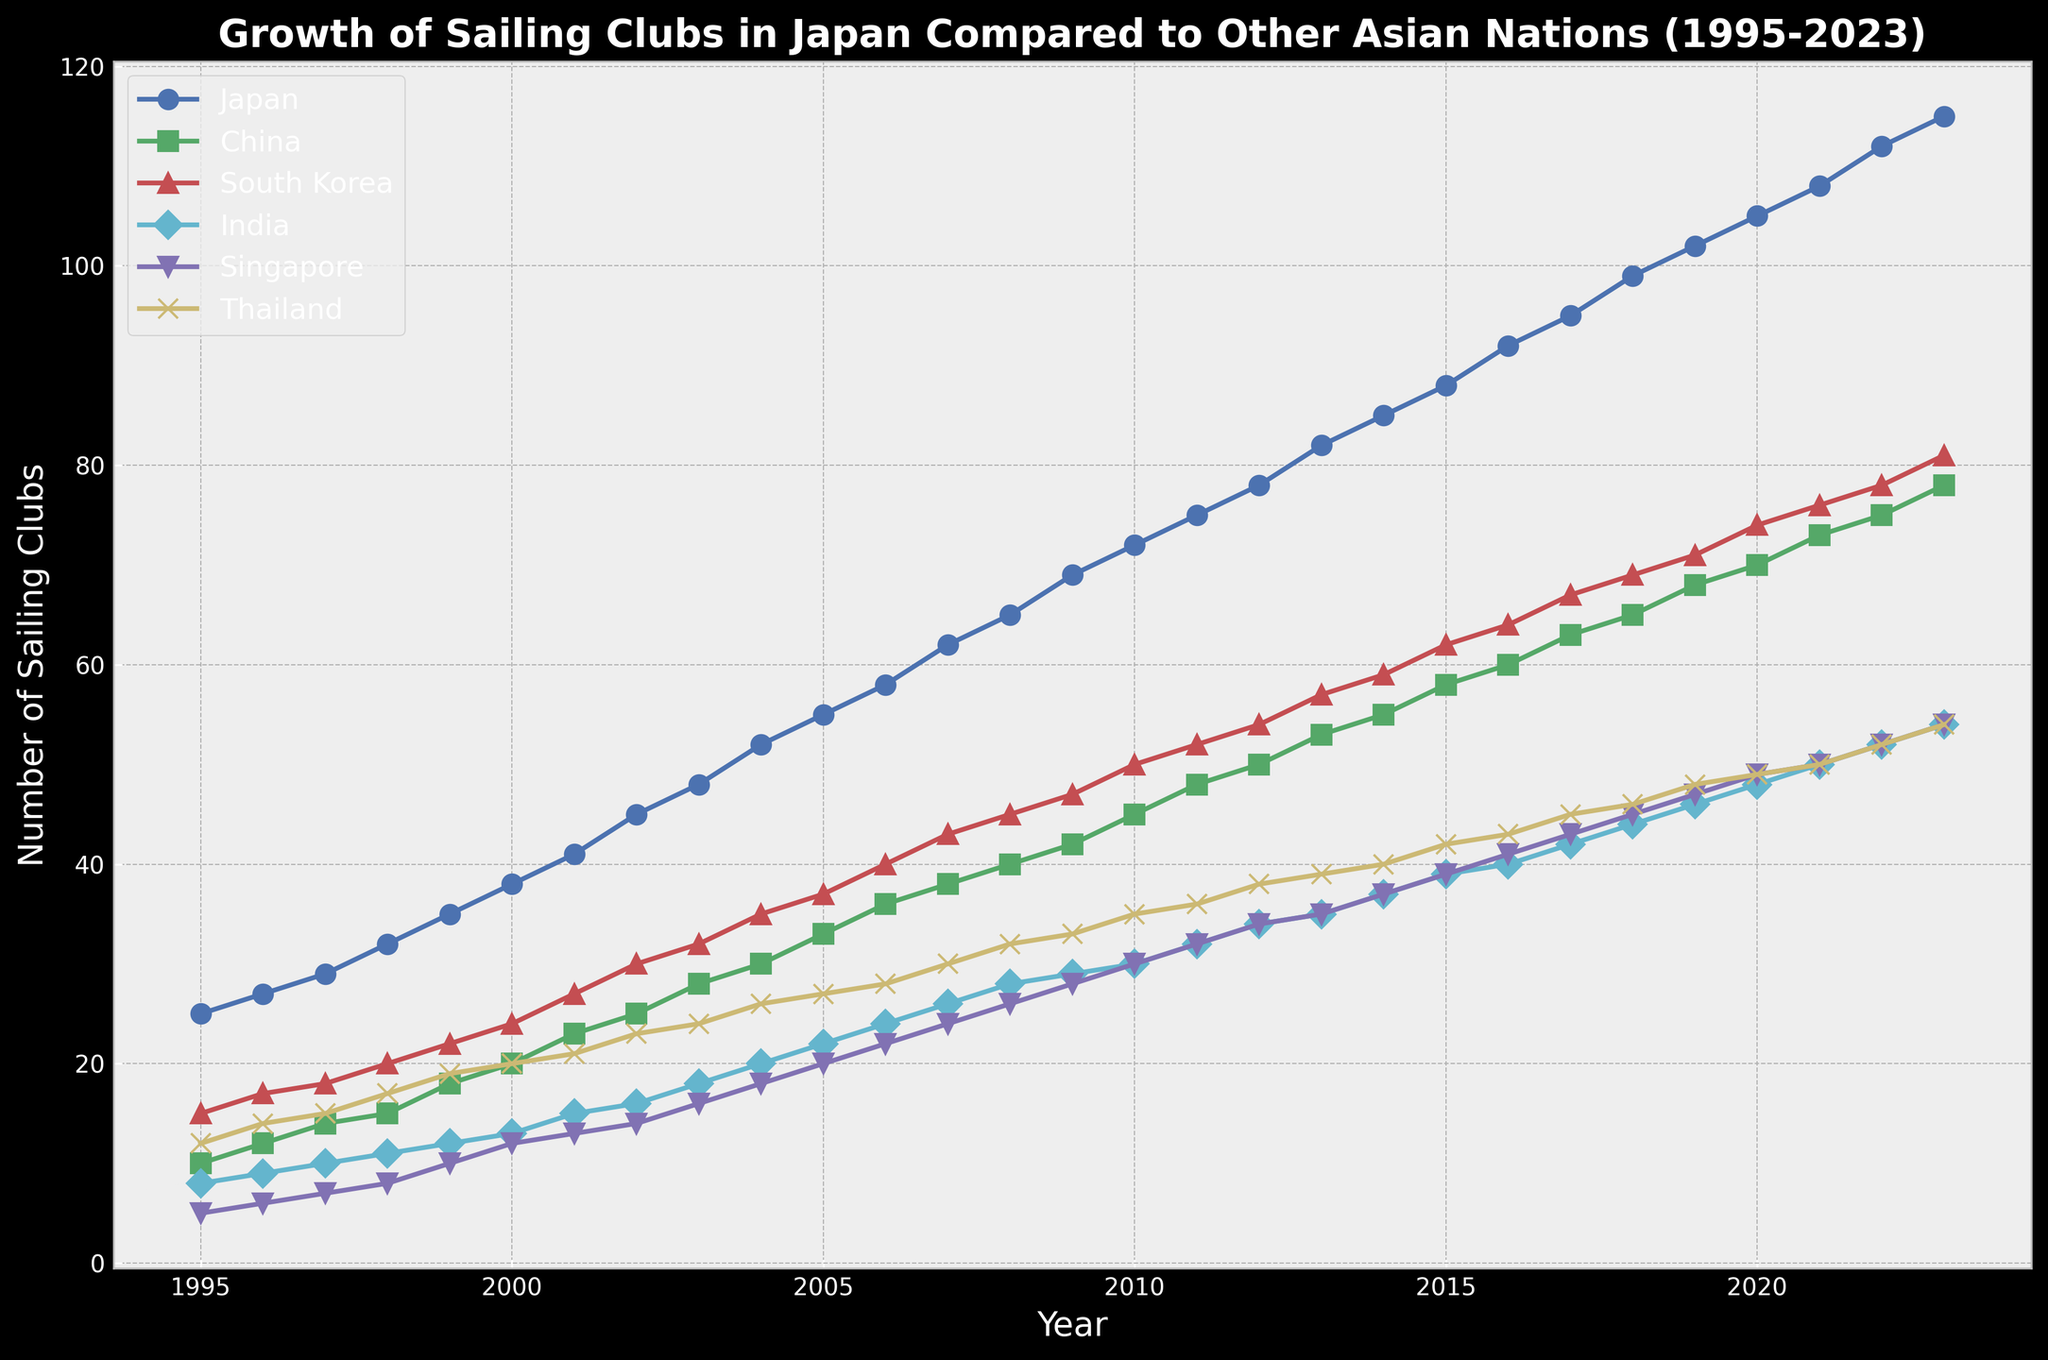How many sailing clubs did Japan and China have in 2003 combined? To find the combined number of sailing clubs in Japan and China in 2003, locate the data points for Japan and China for the year 2003, then add them together. For 2003, Japan had 48 clubs and China had 28 clubs. Therefore, 48 + 28 = 76.
Answer: 76 Between which years did Japan experience the greatest increase in the number of sailing clubs? To determine the period of greatest increase for Japan, compare the increase in the number of sailing clubs between each consecutive year. The steepest increase occurred between 2011 and 2012, where Japan's sailing clubs grew from 75 to 78, an increase of 3 clubs.
Answer: 2011 to 2012 Which country had the highest number of sailing clubs in 2023? To identify the country with the highest number of sailing clubs in 2023, compare the data for each country for the year 2023. Japan had the highest number with 115 sailing clubs.
Answer: Japan From 1995 to 2023, did Singapore ever have more sailing clubs than South Korea? To determine if Singapore ever had more clubs than South Korea, compare their values year by year. At no point did Singapore exceed South Korea in the number of sailing clubs between 1995 and 2023.
Answer: No How many sailing clubs did India have in 2023 compared to 1995? To compare India's number of sailing clubs in 2023 to 1995, find the values for both years. In 1995, India had 8 clubs, and in 2023, it had 54. The difference is 54 - 8 = 46.
Answer: 46 Which country showed the least growth in sailing clubs from 1995 to 2023? To determine the country with the least growth, subtract the number of clubs in 1995 from the number in 2023 for each country and identify the smallest value. Singapore had 5 clubs in 1995 and 54 in 2023, giving a growth of 54 - 5 = 49 clubs. This is the smallest growth among the countries listed.
Answer: Singapore In which year did Thailand first have as many sailing clubs as India? To find the year when Thailand first had as many sailing clubs as India, compare their values year by year. In 2007, both Thailand and India had 26 clubs, which is the first instance of equality.
Answer: 2007 What was the total number of sailing clubs across all listed countries in 2010? To find the total number of sailing clubs across all countries in 2010, sum the values for each country for that year: Japan (72), China (45), South Korea (50), India (30), Singapore (30), Thailand (35). Thus, the total is 72 + 45 + 50 + 30 + 30 + 35 = 262.
Answer: 262 Which two countries had equal numbers of sailing clubs in any year, and in which year did this occur? To find countries with equal numbers of sailing clubs in the same year, review the data across all years. Thailand and India both had 14 sailing clubs in 1996.
Answer: Thailand and India, 1996 